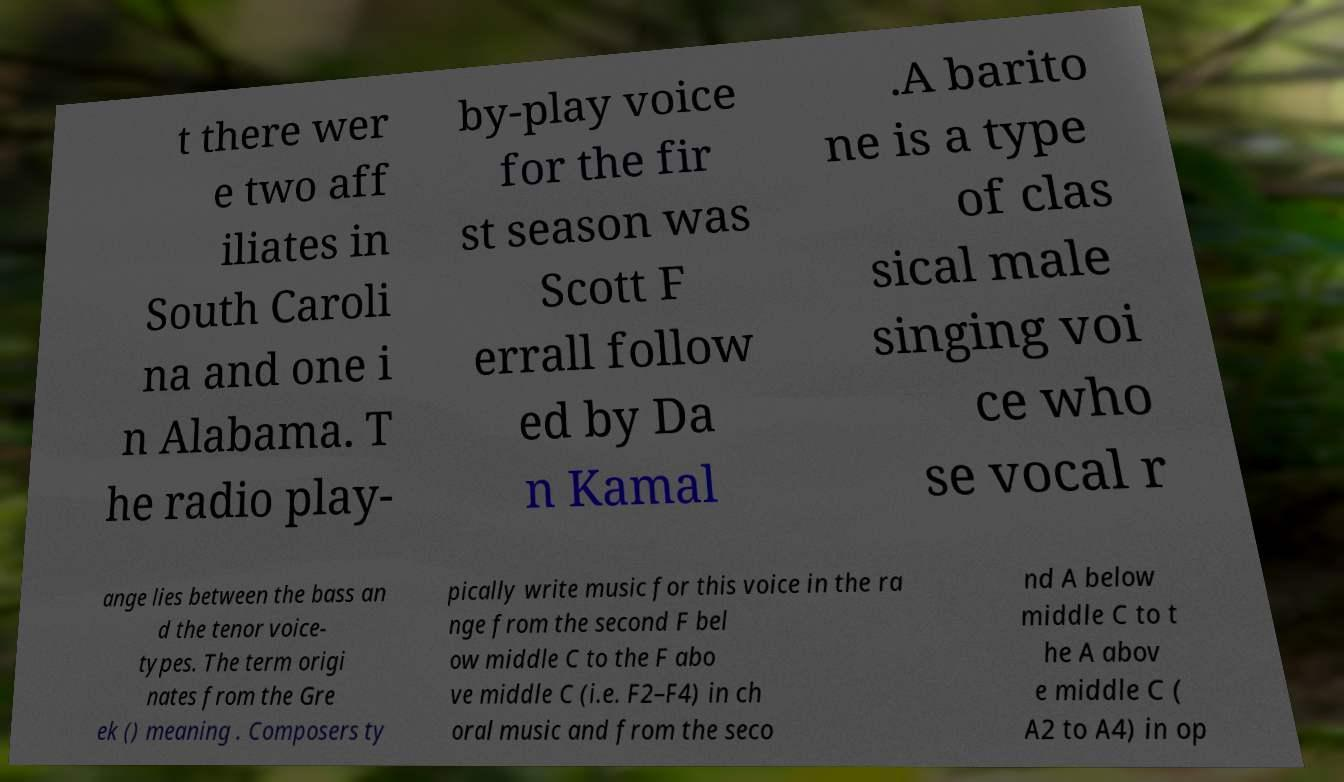For documentation purposes, I need the text within this image transcribed. Could you provide that? t there wer e two aff iliates in South Caroli na and one i n Alabama. T he radio play- by-play voice for the fir st season was Scott F errall follow ed by Da n Kamal .A barito ne is a type of clas sical male singing voi ce who se vocal r ange lies between the bass an d the tenor voice- types. The term origi nates from the Gre ek () meaning . Composers ty pically write music for this voice in the ra nge from the second F bel ow middle C to the F abo ve middle C (i.e. F2–F4) in ch oral music and from the seco nd A below middle C to t he A abov e middle C ( A2 to A4) in op 